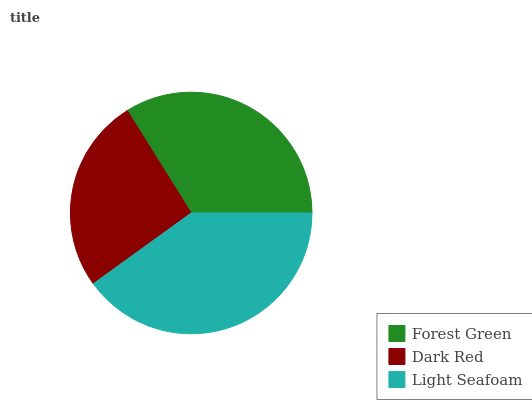Is Dark Red the minimum?
Answer yes or no. Yes. Is Light Seafoam the maximum?
Answer yes or no. Yes. Is Light Seafoam the minimum?
Answer yes or no. No. Is Dark Red the maximum?
Answer yes or no. No. Is Light Seafoam greater than Dark Red?
Answer yes or no. Yes. Is Dark Red less than Light Seafoam?
Answer yes or no. Yes. Is Dark Red greater than Light Seafoam?
Answer yes or no. No. Is Light Seafoam less than Dark Red?
Answer yes or no. No. Is Forest Green the high median?
Answer yes or no. Yes. Is Forest Green the low median?
Answer yes or no. Yes. Is Light Seafoam the high median?
Answer yes or no. No. Is Dark Red the low median?
Answer yes or no. No. 